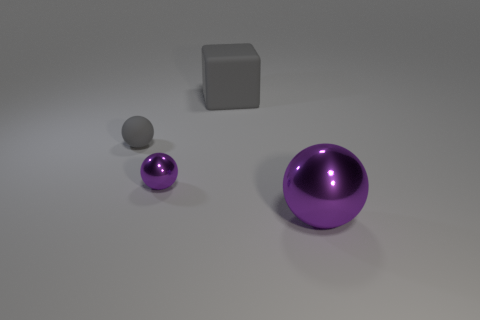What size is the rubber sphere?
Offer a very short reply. Small. There is a big matte cube; is its color the same as the rubber object that is to the left of the gray cube?
Your answer should be compact. Yes. There is a big sphere in front of the tiny sphere that is in front of the tiny thing that is left of the tiny purple metallic thing; what is its color?
Offer a very short reply. Purple. There is a purple ball that is behind the large purple sphere; what number of objects are in front of it?
Make the answer very short. 1. What number of other objects are the same shape as the large gray rubber object?
Your answer should be very brief. 0. How many things are either tiny gray shiny things or large things that are in front of the big gray thing?
Your response must be concise. 1. Is the number of small metallic balls that are behind the tiny gray sphere greater than the number of large matte things in front of the small metallic ball?
Make the answer very short. No. What shape is the purple object that is left of the thing that is behind the tiny sphere to the left of the tiny purple ball?
Ensure brevity in your answer.  Sphere. There is a large thing behind the big thing to the right of the big gray rubber cube; what is its shape?
Your answer should be very brief. Cube. Is there a large brown cube made of the same material as the gray sphere?
Keep it short and to the point. No. 